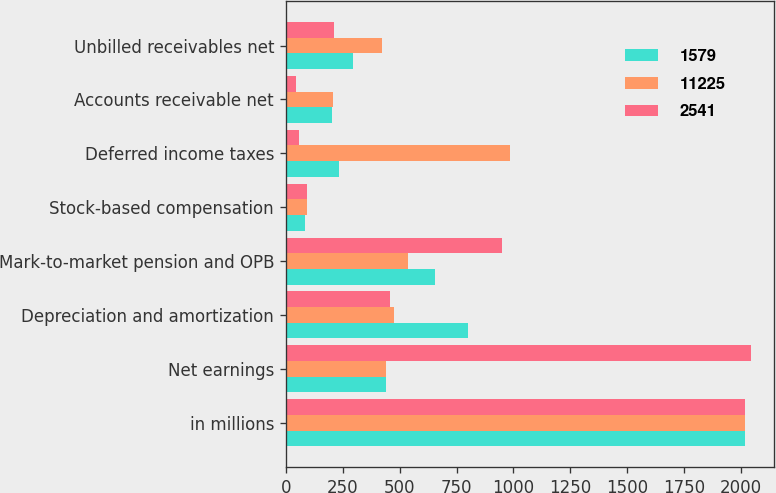<chart> <loc_0><loc_0><loc_500><loc_500><stacked_bar_chart><ecel><fcel>in millions<fcel>Net earnings<fcel>Depreciation and amortization<fcel>Mark-to-market pension and OPB<fcel>Stock-based compensation<fcel>Deferred income taxes<fcel>Accounts receivable net<fcel>Unbilled receivables net<nl><fcel>1579<fcel>2018<fcel>439<fcel>800<fcel>655<fcel>86<fcel>234<fcel>202<fcel>297<nl><fcel>11225<fcel>2017<fcel>439<fcel>475<fcel>536<fcel>94<fcel>985<fcel>209<fcel>422<nl><fcel>2541<fcel>2016<fcel>2043<fcel>456<fcel>950<fcel>93<fcel>60<fcel>46<fcel>211<nl></chart> 